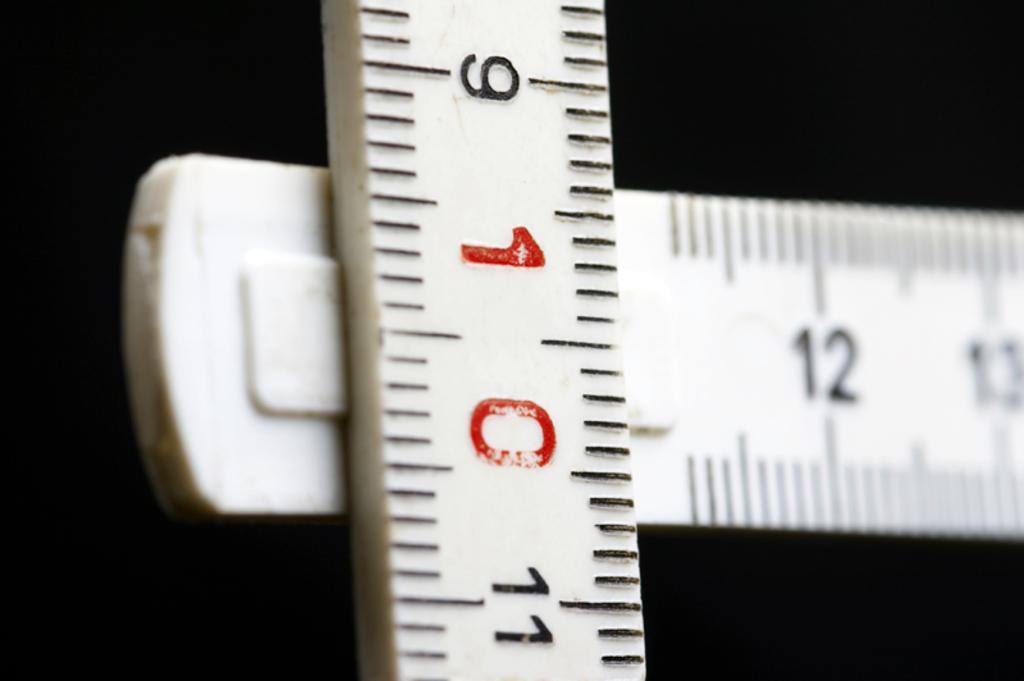What is the red number on the ruler?
Provide a succinct answer. 10. What number is in red?
Your answer should be compact. 10. 